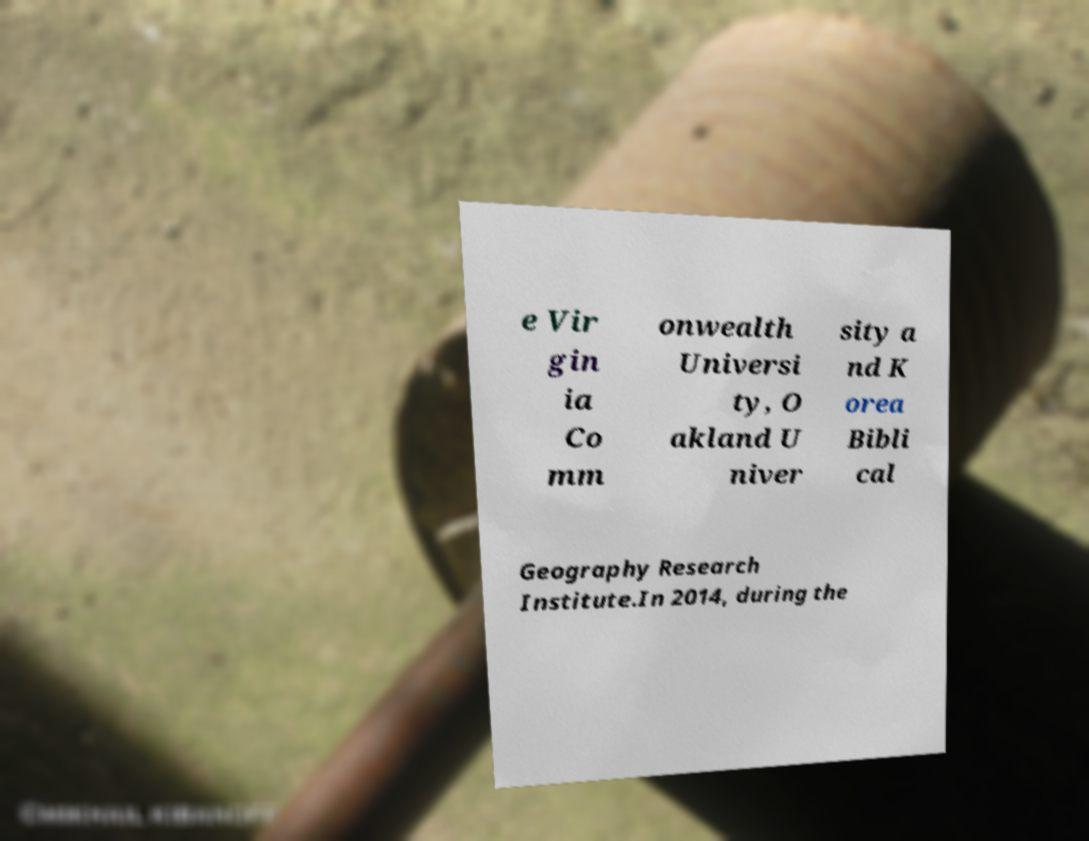There's text embedded in this image that I need extracted. Can you transcribe it verbatim? e Vir gin ia Co mm onwealth Universi ty, O akland U niver sity a nd K orea Bibli cal Geography Research Institute.In 2014, during the 